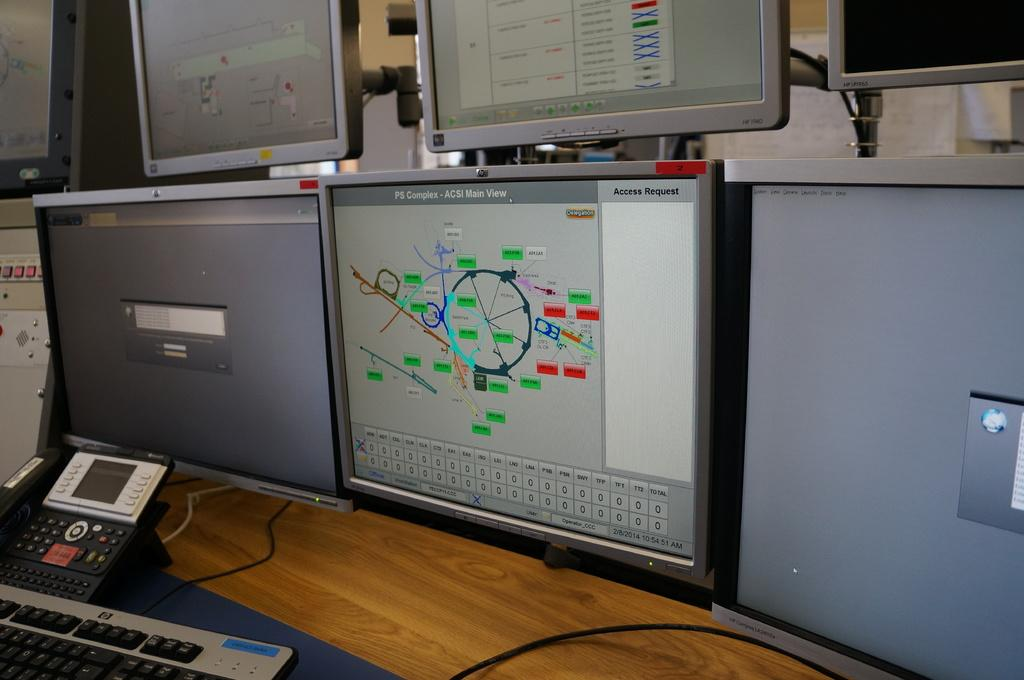<image>
Render a clear and concise summary of the photo. The monitor on the right says PS Complex. 